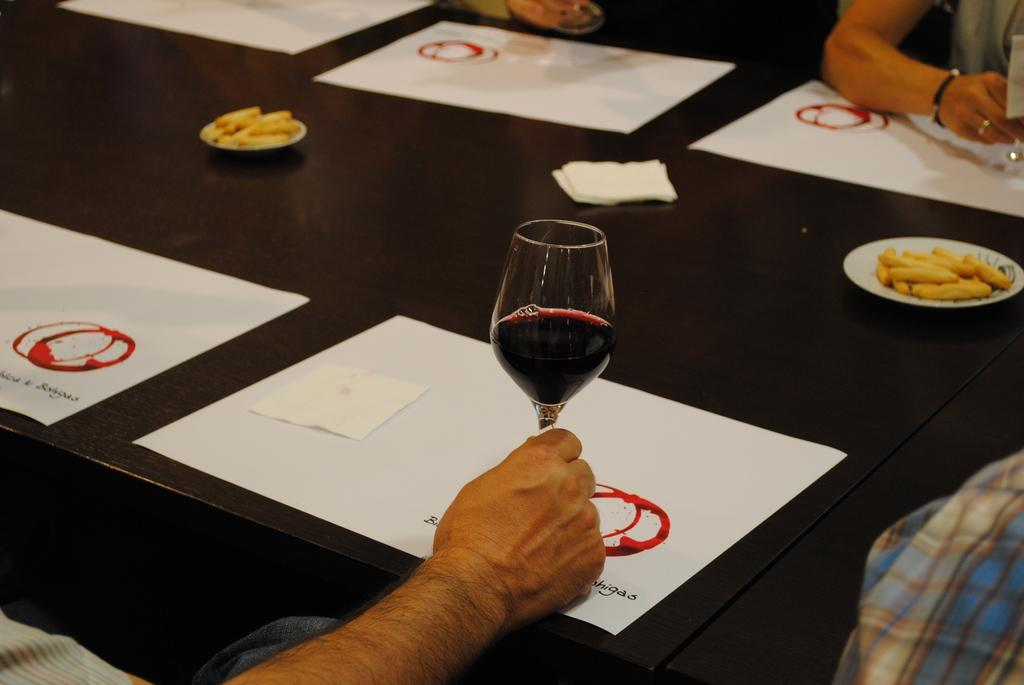What type of furniture is present in the image? There is a table in the image. What items can be seen on the table? There are paper items and plates on the table. What type of container is visible on the table? There is a glass on the table on the table. Can you see a flock of birds flying over the table in the image? There is no flock of birds visible in the image. 